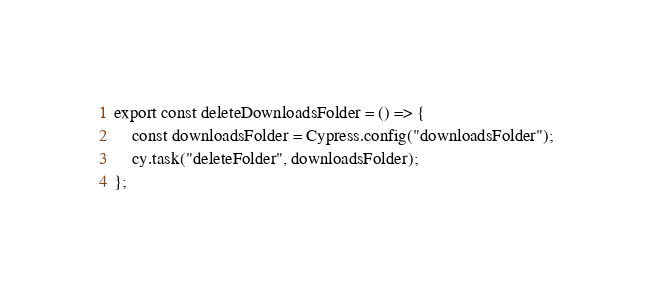Convert code to text. <code><loc_0><loc_0><loc_500><loc_500><_JavaScript_>export const deleteDownloadsFolder = () => {
    const downloadsFolder = Cypress.config("downloadsFolder");
    cy.task("deleteFolder", downloadsFolder);
};
</code> 